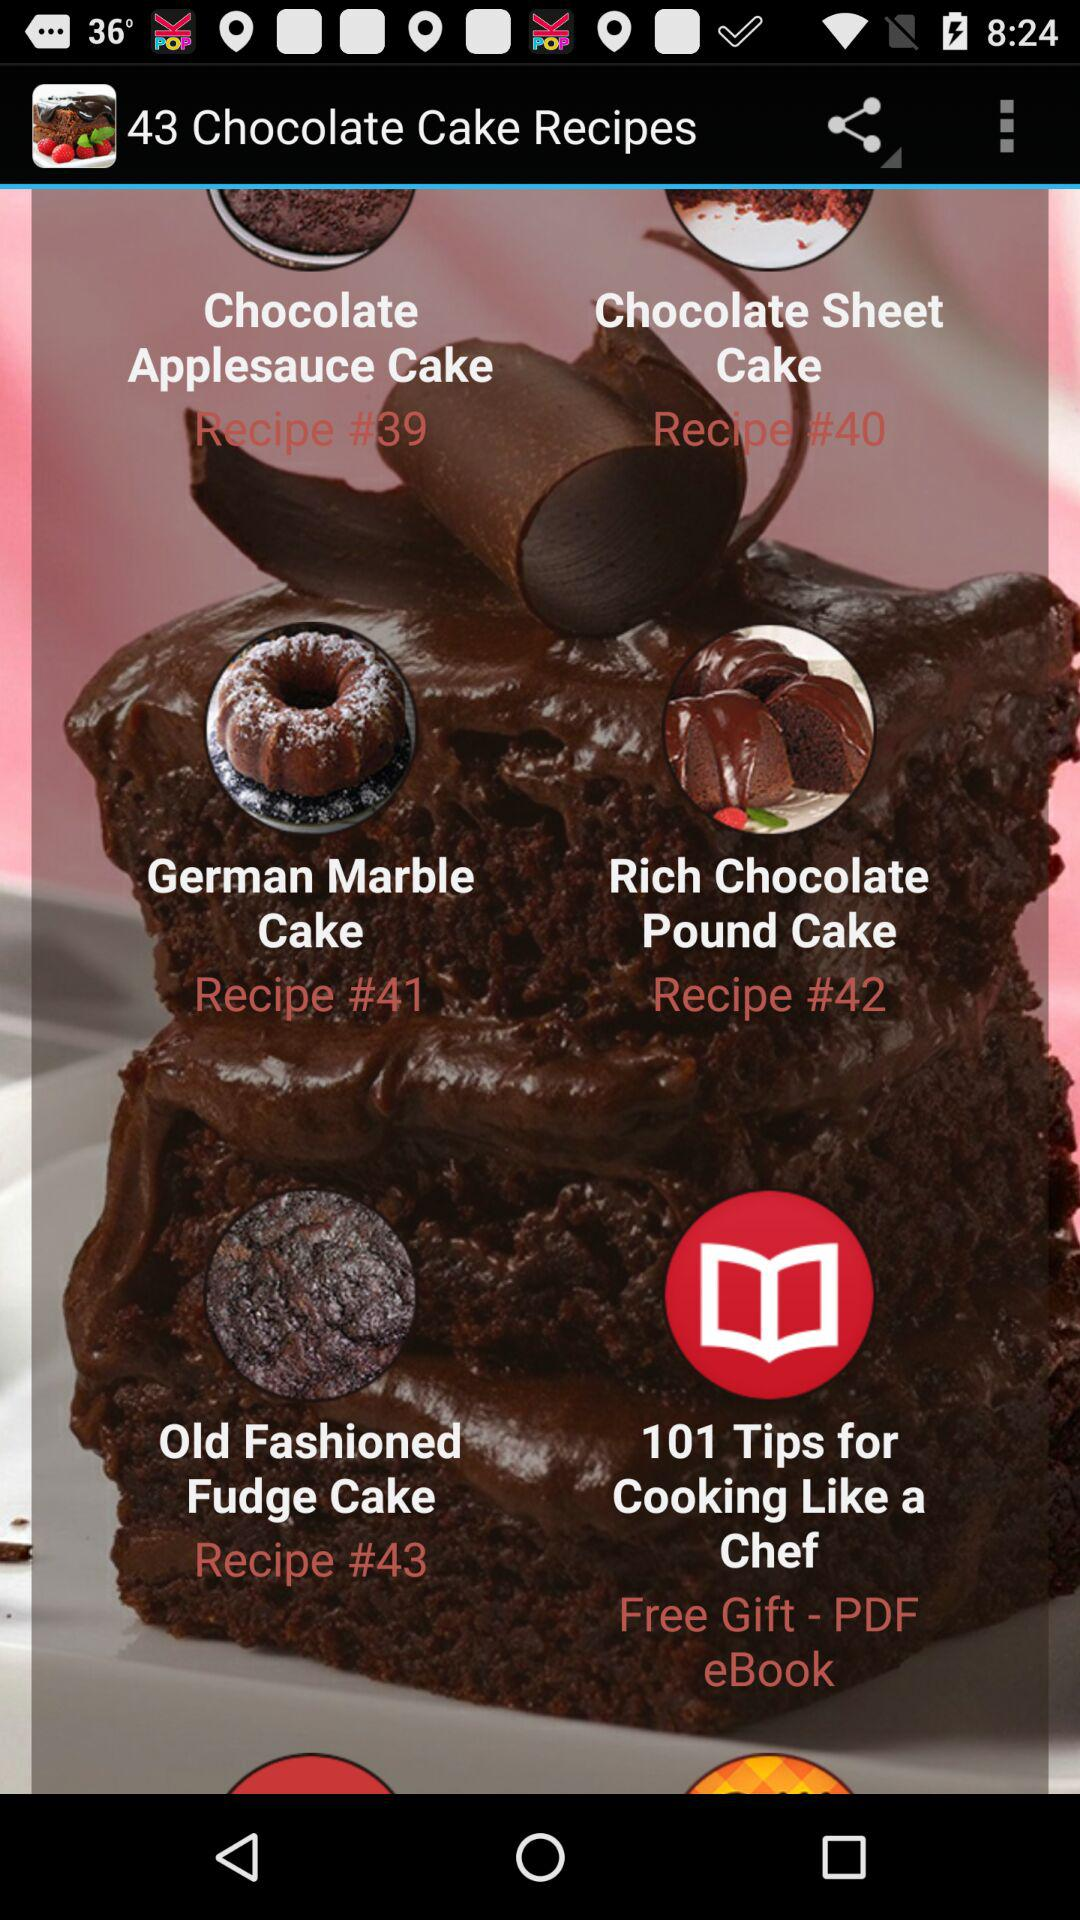What does recipe number 43 stand for? Recipe number 43 stands for "Old Fashioned Fudge Cake". 